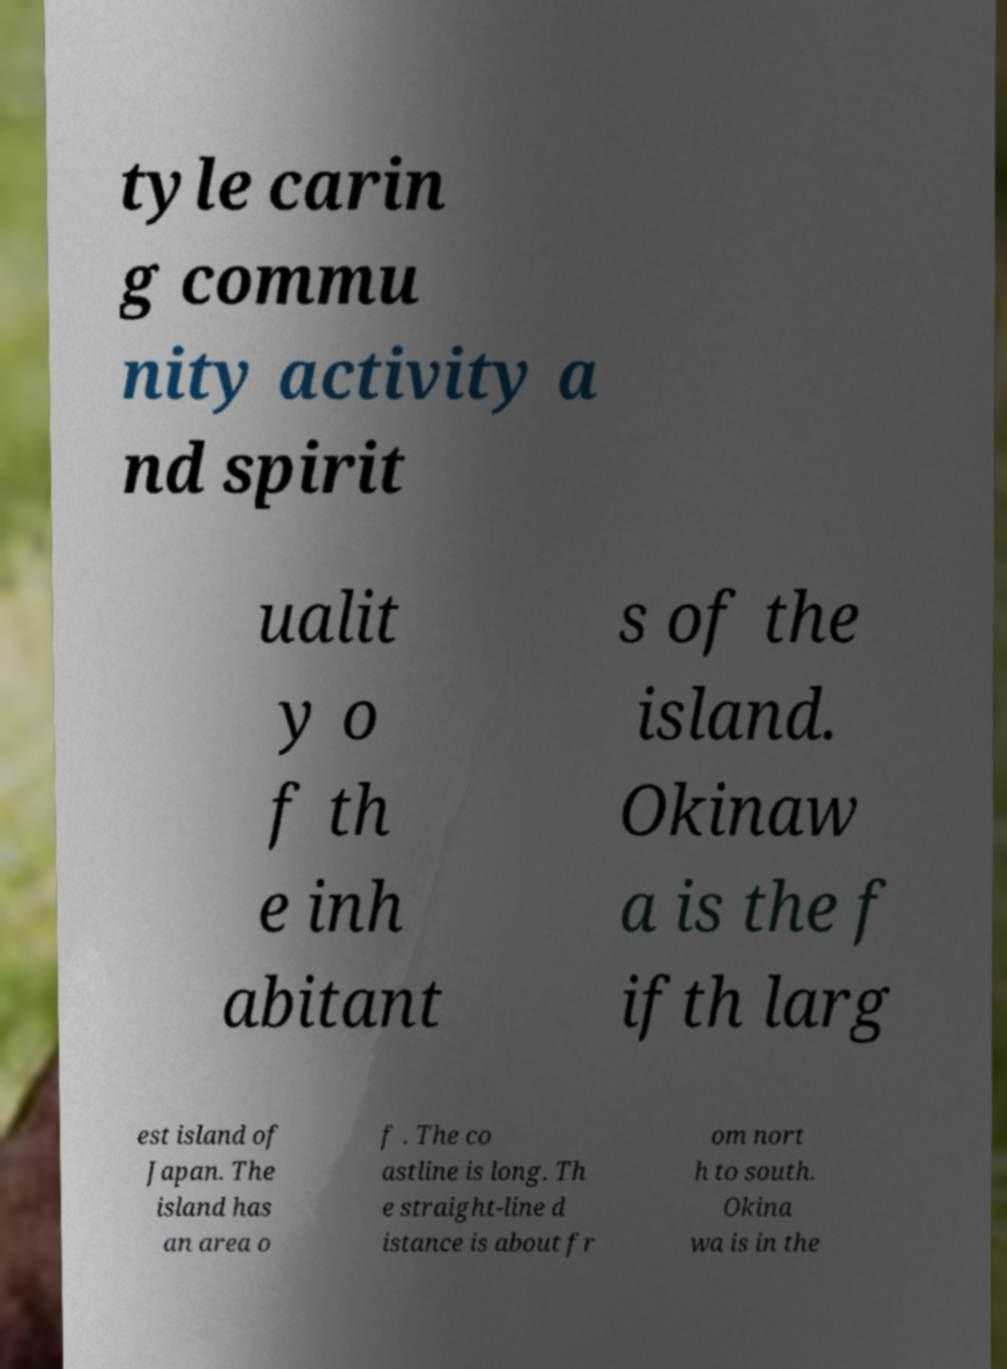Please read and relay the text visible in this image. What does it say? tyle carin g commu nity activity a nd spirit ualit y o f th e inh abitant s of the island. Okinaw a is the f ifth larg est island of Japan. The island has an area o f . The co astline is long. Th e straight-line d istance is about fr om nort h to south. Okina wa is in the 